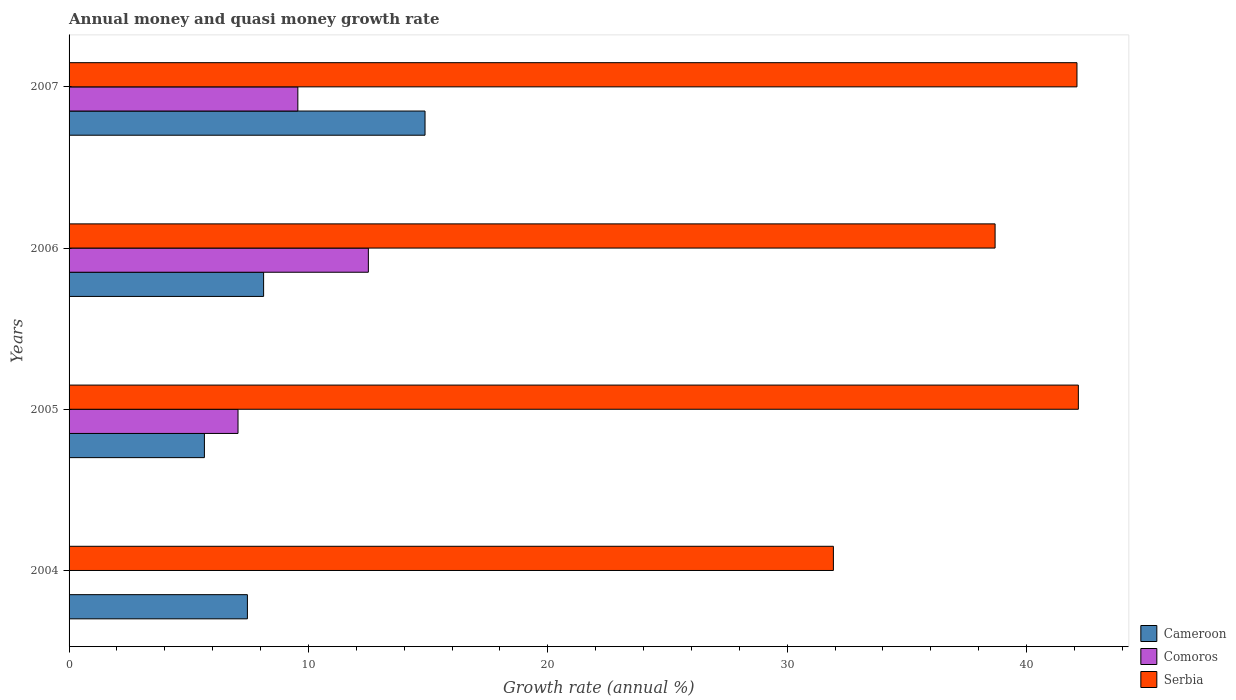What is the label of the 4th group of bars from the top?
Give a very brief answer. 2004. What is the growth rate in Comoros in 2006?
Your answer should be very brief. 12.5. Across all years, what is the maximum growth rate in Cameroon?
Your answer should be compact. 14.87. Across all years, what is the minimum growth rate in Serbia?
Make the answer very short. 31.93. What is the total growth rate in Serbia in the graph?
Offer a terse response. 154.9. What is the difference between the growth rate in Cameroon in 2006 and that in 2007?
Your answer should be very brief. -6.74. What is the difference between the growth rate in Cameroon in 2006 and the growth rate in Comoros in 2007?
Give a very brief answer. -1.43. What is the average growth rate in Comoros per year?
Keep it short and to the point. 7.28. In the year 2005, what is the difference between the growth rate in Cameroon and growth rate in Comoros?
Your response must be concise. -1.4. In how many years, is the growth rate in Comoros greater than 36 %?
Provide a succinct answer. 0. What is the ratio of the growth rate in Cameroon in 2004 to that in 2007?
Give a very brief answer. 0.5. Is the difference between the growth rate in Cameroon in 2006 and 2007 greater than the difference between the growth rate in Comoros in 2006 and 2007?
Offer a terse response. No. What is the difference between the highest and the second highest growth rate in Comoros?
Make the answer very short. 2.95. What is the difference between the highest and the lowest growth rate in Comoros?
Make the answer very short. 12.5. In how many years, is the growth rate in Comoros greater than the average growth rate in Comoros taken over all years?
Make the answer very short. 2. Is the sum of the growth rate in Cameroon in 2005 and 2007 greater than the maximum growth rate in Comoros across all years?
Make the answer very short. Yes. Are all the bars in the graph horizontal?
Offer a very short reply. Yes. What is the difference between two consecutive major ticks on the X-axis?
Offer a very short reply. 10. Where does the legend appear in the graph?
Provide a short and direct response. Bottom right. How many legend labels are there?
Offer a very short reply. 3. How are the legend labels stacked?
Ensure brevity in your answer.  Vertical. What is the title of the graph?
Make the answer very short. Annual money and quasi money growth rate. What is the label or title of the X-axis?
Provide a short and direct response. Growth rate (annual %). What is the Growth rate (annual %) in Cameroon in 2004?
Keep it short and to the point. 7.45. What is the Growth rate (annual %) of Comoros in 2004?
Offer a terse response. 0. What is the Growth rate (annual %) of Serbia in 2004?
Your response must be concise. 31.93. What is the Growth rate (annual %) of Cameroon in 2005?
Offer a very short reply. 5.65. What is the Growth rate (annual %) of Comoros in 2005?
Your answer should be very brief. 7.06. What is the Growth rate (annual %) in Serbia in 2005?
Give a very brief answer. 42.17. What is the Growth rate (annual %) of Cameroon in 2006?
Keep it short and to the point. 8.13. What is the Growth rate (annual %) of Comoros in 2006?
Offer a terse response. 12.5. What is the Growth rate (annual %) of Serbia in 2006?
Offer a terse response. 38.69. What is the Growth rate (annual %) of Cameroon in 2007?
Keep it short and to the point. 14.87. What is the Growth rate (annual %) in Comoros in 2007?
Make the answer very short. 9.56. What is the Growth rate (annual %) in Serbia in 2007?
Provide a short and direct response. 42.11. Across all years, what is the maximum Growth rate (annual %) of Cameroon?
Provide a short and direct response. 14.87. Across all years, what is the maximum Growth rate (annual %) of Comoros?
Make the answer very short. 12.5. Across all years, what is the maximum Growth rate (annual %) in Serbia?
Offer a terse response. 42.17. Across all years, what is the minimum Growth rate (annual %) in Cameroon?
Give a very brief answer. 5.65. Across all years, what is the minimum Growth rate (annual %) of Comoros?
Your answer should be compact. 0. Across all years, what is the minimum Growth rate (annual %) in Serbia?
Provide a succinct answer. 31.93. What is the total Growth rate (annual %) of Cameroon in the graph?
Offer a very short reply. 36.1. What is the total Growth rate (annual %) in Comoros in the graph?
Keep it short and to the point. 29.12. What is the total Growth rate (annual %) of Serbia in the graph?
Your answer should be very brief. 154.9. What is the difference between the Growth rate (annual %) in Cameroon in 2004 and that in 2005?
Your answer should be very brief. 1.8. What is the difference between the Growth rate (annual %) in Serbia in 2004 and that in 2005?
Provide a short and direct response. -10.23. What is the difference between the Growth rate (annual %) of Cameroon in 2004 and that in 2006?
Give a very brief answer. -0.68. What is the difference between the Growth rate (annual %) in Serbia in 2004 and that in 2006?
Keep it short and to the point. -6.76. What is the difference between the Growth rate (annual %) in Cameroon in 2004 and that in 2007?
Ensure brevity in your answer.  -7.42. What is the difference between the Growth rate (annual %) of Serbia in 2004 and that in 2007?
Your answer should be compact. -10.18. What is the difference between the Growth rate (annual %) of Cameroon in 2005 and that in 2006?
Your answer should be very brief. -2.47. What is the difference between the Growth rate (annual %) of Comoros in 2005 and that in 2006?
Keep it short and to the point. -5.45. What is the difference between the Growth rate (annual %) in Serbia in 2005 and that in 2006?
Offer a very short reply. 3.48. What is the difference between the Growth rate (annual %) in Cameroon in 2005 and that in 2007?
Make the answer very short. -9.22. What is the difference between the Growth rate (annual %) in Comoros in 2005 and that in 2007?
Your response must be concise. -2.5. What is the difference between the Growth rate (annual %) of Serbia in 2005 and that in 2007?
Provide a succinct answer. 0.06. What is the difference between the Growth rate (annual %) in Cameroon in 2006 and that in 2007?
Make the answer very short. -6.74. What is the difference between the Growth rate (annual %) in Comoros in 2006 and that in 2007?
Offer a very short reply. 2.95. What is the difference between the Growth rate (annual %) in Serbia in 2006 and that in 2007?
Provide a short and direct response. -3.42. What is the difference between the Growth rate (annual %) of Cameroon in 2004 and the Growth rate (annual %) of Comoros in 2005?
Keep it short and to the point. 0.39. What is the difference between the Growth rate (annual %) of Cameroon in 2004 and the Growth rate (annual %) of Serbia in 2005?
Keep it short and to the point. -34.72. What is the difference between the Growth rate (annual %) of Cameroon in 2004 and the Growth rate (annual %) of Comoros in 2006?
Your answer should be very brief. -5.05. What is the difference between the Growth rate (annual %) in Cameroon in 2004 and the Growth rate (annual %) in Serbia in 2006?
Give a very brief answer. -31.24. What is the difference between the Growth rate (annual %) in Cameroon in 2004 and the Growth rate (annual %) in Comoros in 2007?
Provide a short and direct response. -2.11. What is the difference between the Growth rate (annual %) in Cameroon in 2004 and the Growth rate (annual %) in Serbia in 2007?
Offer a very short reply. -34.66. What is the difference between the Growth rate (annual %) of Cameroon in 2005 and the Growth rate (annual %) of Comoros in 2006?
Offer a terse response. -6.85. What is the difference between the Growth rate (annual %) in Cameroon in 2005 and the Growth rate (annual %) in Serbia in 2006?
Give a very brief answer. -33.03. What is the difference between the Growth rate (annual %) in Comoros in 2005 and the Growth rate (annual %) in Serbia in 2006?
Your response must be concise. -31.63. What is the difference between the Growth rate (annual %) in Cameroon in 2005 and the Growth rate (annual %) in Comoros in 2007?
Keep it short and to the point. -3.9. What is the difference between the Growth rate (annual %) of Cameroon in 2005 and the Growth rate (annual %) of Serbia in 2007?
Give a very brief answer. -36.46. What is the difference between the Growth rate (annual %) of Comoros in 2005 and the Growth rate (annual %) of Serbia in 2007?
Offer a very short reply. -35.05. What is the difference between the Growth rate (annual %) of Cameroon in 2006 and the Growth rate (annual %) of Comoros in 2007?
Provide a succinct answer. -1.43. What is the difference between the Growth rate (annual %) in Cameroon in 2006 and the Growth rate (annual %) in Serbia in 2007?
Offer a very short reply. -33.98. What is the difference between the Growth rate (annual %) of Comoros in 2006 and the Growth rate (annual %) of Serbia in 2007?
Ensure brevity in your answer.  -29.61. What is the average Growth rate (annual %) of Cameroon per year?
Keep it short and to the point. 9.03. What is the average Growth rate (annual %) in Comoros per year?
Offer a very short reply. 7.28. What is the average Growth rate (annual %) of Serbia per year?
Make the answer very short. 38.72. In the year 2004, what is the difference between the Growth rate (annual %) of Cameroon and Growth rate (annual %) of Serbia?
Provide a succinct answer. -24.48. In the year 2005, what is the difference between the Growth rate (annual %) in Cameroon and Growth rate (annual %) in Comoros?
Provide a succinct answer. -1.4. In the year 2005, what is the difference between the Growth rate (annual %) in Cameroon and Growth rate (annual %) in Serbia?
Offer a terse response. -36.51. In the year 2005, what is the difference between the Growth rate (annual %) in Comoros and Growth rate (annual %) in Serbia?
Keep it short and to the point. -35.11. In the year 2006, what is the difference between the Growth rate (annual %) in Cameroon and Growth rate (annual %) in Comoros?
Your response must be concise. -4.38. In the year 2006, what is the difference between the Growth rate (annual %) in Cameroon and Growth rate (annual %) in Serbia?
Provide a short and direct response. -30.56. In the year 2006, what is the difference between the Growth rate (annual %) of Comoros and Growth rate (annual %) of Serbia?
Make the answer very short. -26.18. In the year 2007, what is the difference between the Growth rate (annual %) of Cameroon and Growth rate (annual %) of Comoros?
Provide a short and direct response. 5.31. In the year 2007, what is the difference between the Growth rate (annual %) of Cameroon and Growth rate (annual %) of Serbia?
Provide a succinct answer. -27.24. In the year 2007, what is the difference between the Growth rate (annual %) in Comoros and Growth rate (annual %) in Serbia?
Offer a terse response. -32.55. What is the ratio of the Growth rate (annual %) in Cameroon in 2004 to that in 2005?
Keep it short and to the point. 1.32. What is the ratio of the Growth rate (annual %) in Serbia in 2004 to that in 2005?
Your answer should be compact. 0.76. What is the ratio of the Growth rate (annual %) of Cameroon in 2004 to that in 2006?
Keep it short and to the point. 0.92. What is the ratio of the Growth rate (annual %) in Serbia in 2004 to that in 2006?
Give a very brief answer. 0.83. What is the ratio of the Growth rate (annual %) of Cameroon in 2004 to that in 2007?
Your response must be concise. 0.5. What is the ratio of the Growth rate (annual %) of Serbia in 2004 to that in 2007?
Keep it short and to the point. 0.76. What is the ratio of the Growth rate (annual %) in Cameroon in 2005 to that in 2006?
Give a very brief answer. 0.7. What is the ratio of the Growth rate (annual %) in Comoros in 2005 to that in 2006?
Provide a short and direct response. 0.56. What is the ratio of the Growth rate (annual %) of Serbia in 2005 to that in 2006?
Your response must be concise. 1.09. What is the ratio of the Growth rate (annual %) in Cameroon in 2005 to that in 2007?
Provide a short and direct response. 0.38. What is the ratio of the Growth rate (annual %) of Comoros in 2005 to that in 2007?
Offer a very short reply. 0.74. What is the ratio of the Growth rate (annual %) in Cameroon in 2006 to that in 2007?
Provide a succinct answer. 0.55. What is the ratio of the Growth rate (annual %) of Comoros in 2006 to that in 2007?
Keep it short and to the point. 1.31. What is the ratio of the Growth rate (annual %) of Serbia in 2006 to that in 2007?
Offer a very short reply. 0.92. What is the difference between the highest and the second highest Growth rate (annual %) of Cameroon?
Offer a terse response. 6.74. What is the difference between the highest and the second highest Growth rate (annual %) of Comoros?
Provide a short and direct response. 2.95. What is the difference between the highest and the second highest Growth rate (annual %) of Serbia?
Provide a succinct answer. 0.06. What is the difference between the highest and the lowest Growth rate (annual %) in Cameroon?
Provide a short and direct response. 9.22. What is the difference between the highest and the lowest Growth rate (annual %) in Comoros?
Your answer should be very brief. 12.5. What is the difference between the highest and the lowest Growth rate (annual %) of Serbia?
Ensure brevity in your answer.  10.23. 